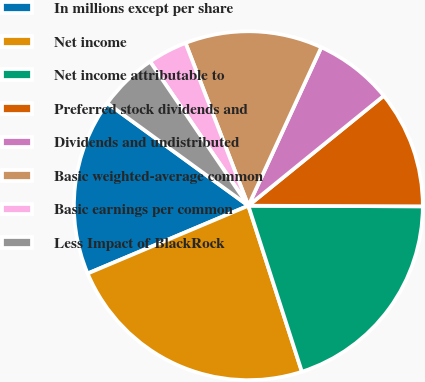Convert chart. <chart><loc_0><loc_0><loc_500><loc_500><pie_chart><fcel>In millions except per share<fcel>Net income<fcel>Net income attributable to<fcel>Preferred stock dividends and<fcel>Dividends and undistributed<fcel>Basic weighted-average common<fcel>Basic earnings per common<fcel>Less Impact of BlackRock<nl><fcel>16.36%<fcel>23.61%<fcel>19.98%<fcel>10.91%<fcel>7.28%<fcel>12.73%<fcel>3.66%<fcel>5.47%<nl></chart> 